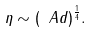Convert formula to latex. <formula><loc_0><loc_0><loc_500><loc_500>\eta \sim ( \ A d ) ^ { \frac { 1 } { 4 } } .</formula> 